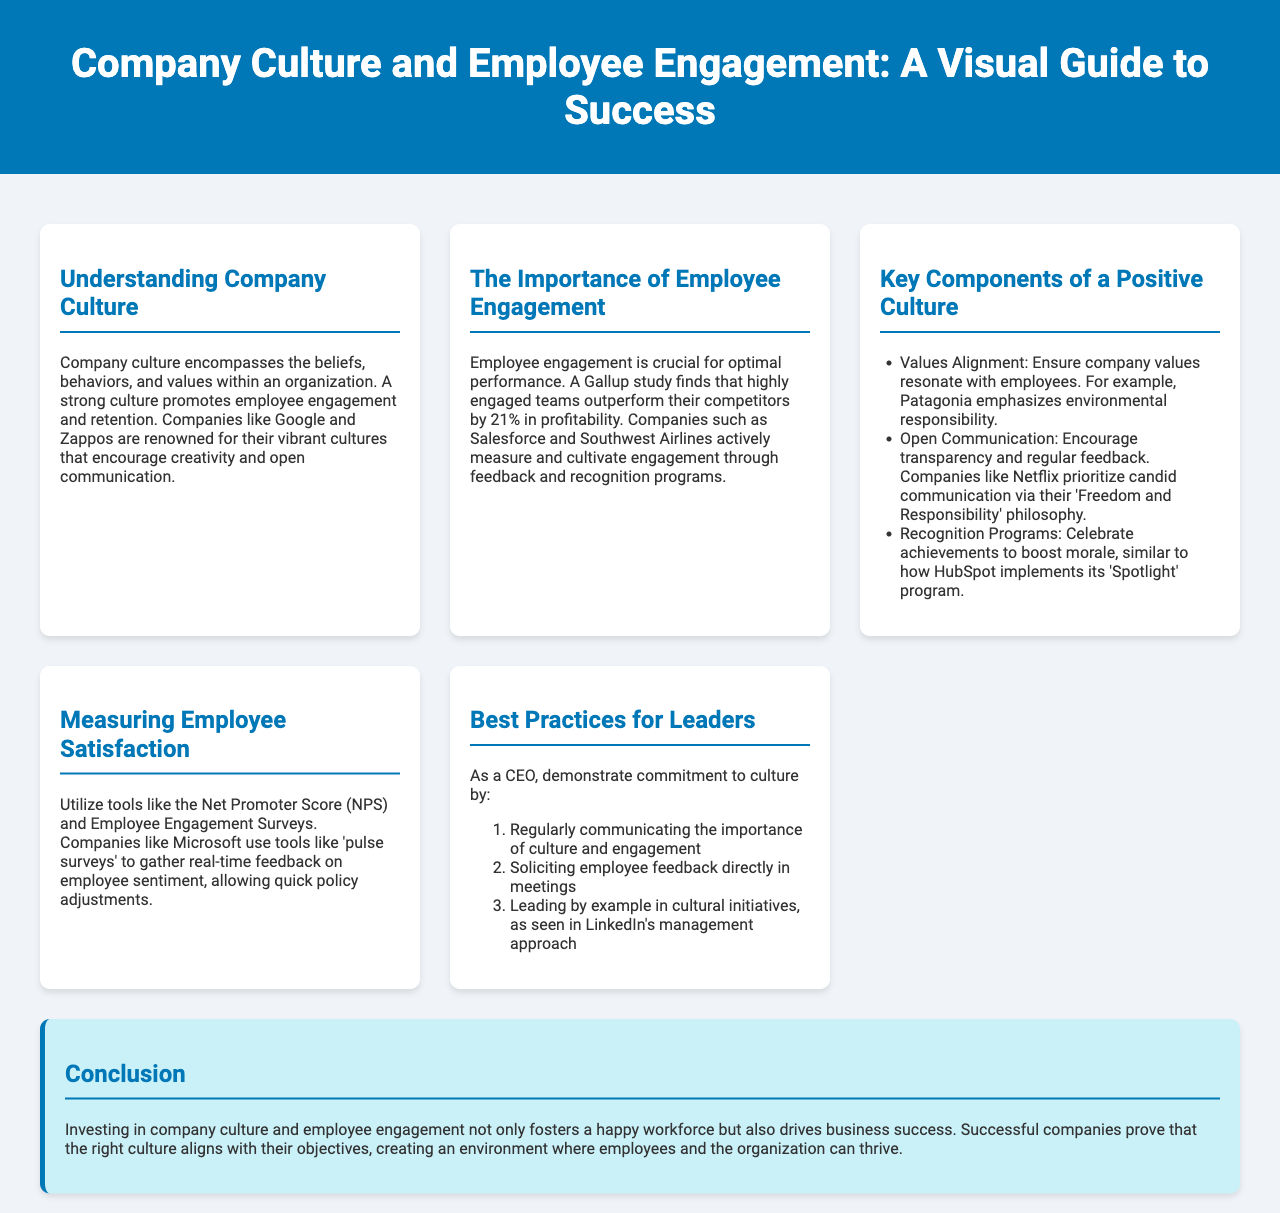What is the title of the document? The title is the main heading of the document, which is prominently displayed in the header.
Answer: Company Culture and Employee Engagement: A Visual Guide to Success Which company emphasizes environmental responsibility? The document mentions a specific company that aligns its values with environmental responsibility.
Answer: Patagonia What percentage do highly engaged teams outperform their competitors by? This percentage was cited in a Gallup study referenced in the document.
Answer: 21% What is one tool mentioned for measuring employee satisfaction? The document lists specific tools used for gathering employee feedback regarding satisfaction.
Answer: Net Promoter Score What philosophy does Netflix prioritize? The philosophy mentioned in the document is tied to their approach to communication.
Answer: Freedom and Responsibility What is the first best practice for leaders? The document provides a numbered list of practices that leaders should adopt.
Answer: Regularly communicating the importance of culture and engagement What color is the header background? The document describes the visual style, including specific colors used in the design.
Answer: #0077b6 Which program does HubSpot implement to celebrate achievements? This program is mentioned as an example of how recognition boosts morale.
Answer: Spotlight 